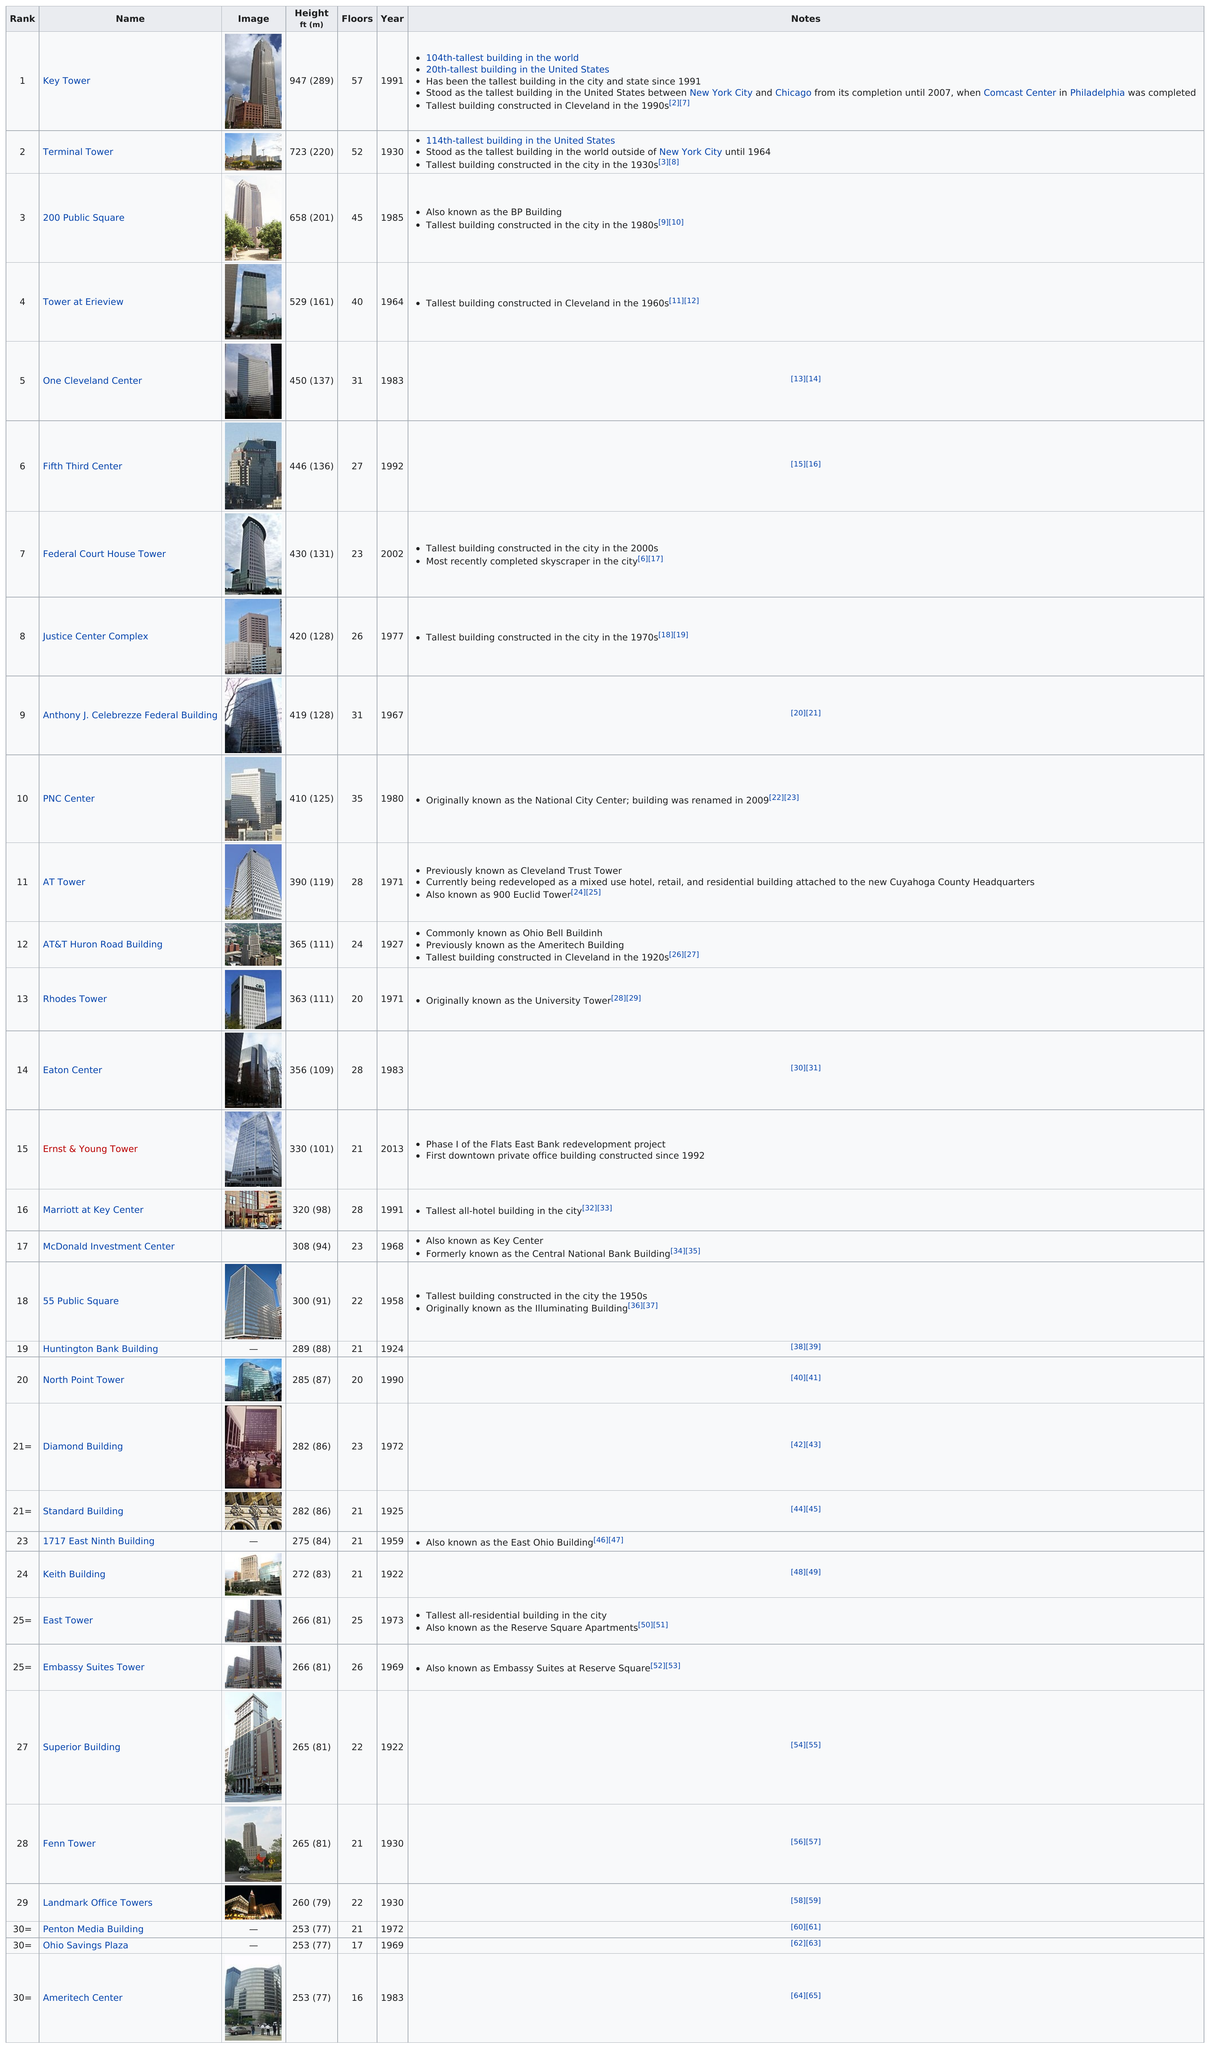Give some essential details in this illustration. The Ernst & Young Tower is the first private office building constructed in downtown since 1992. The height difference between Key Tower and 55 Public Square is 647 feet. After 1950, a total of 24 buildings were constructed. Out of the total number of buildings in the area, those with fewer than 20 floors account for 2. When the Key Tower was completed in 1991, the Terminal Tower was the previous tallest building that had been constructed. 